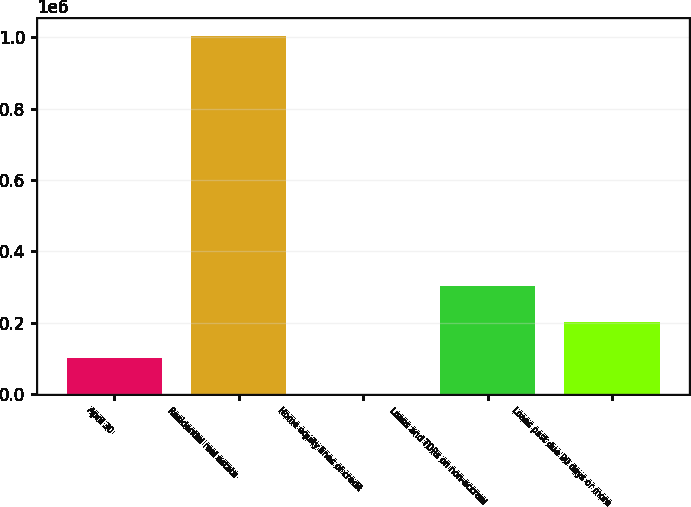<chart> <loc_0><loc_0><loc_500><loc_500><bar_chart><fcel>April 30<fcel>Residential real estate<fcel>Home equity lines of credit<fcel>Loans and TDRs on non-accrual<fcel>Loans past due 90 days or more<nl><fcel>100750<fcel>1.00428e+06<fcel>357<fcel>301535<fcel>201142<nl></chart> 